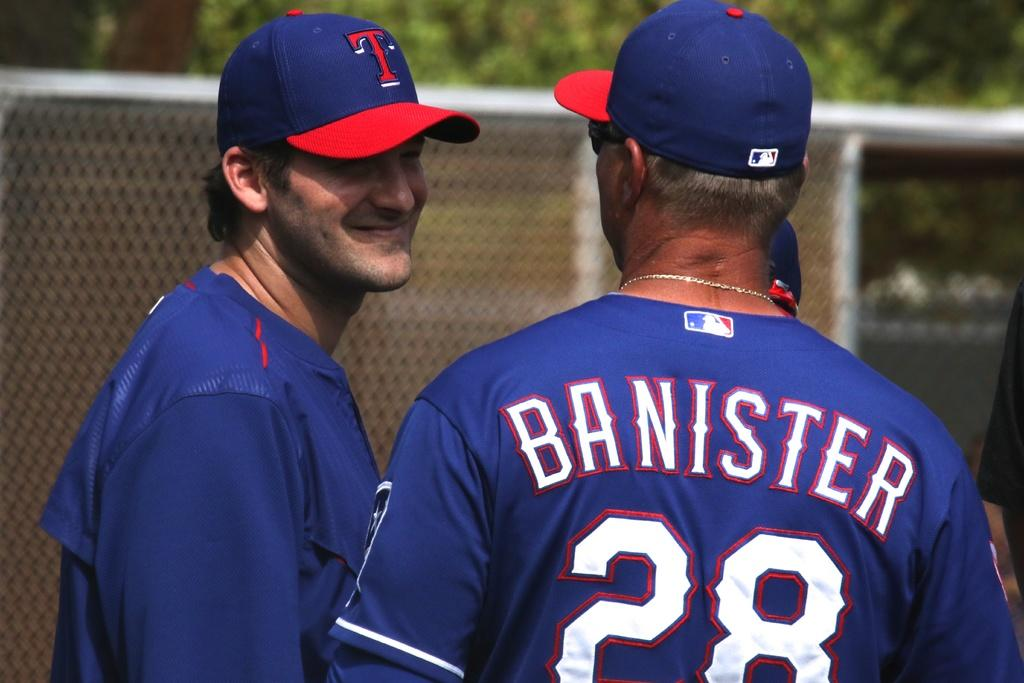<image>
Create a compact narrative representing the image presented. Banister wears number 28 and is talking with another player. 